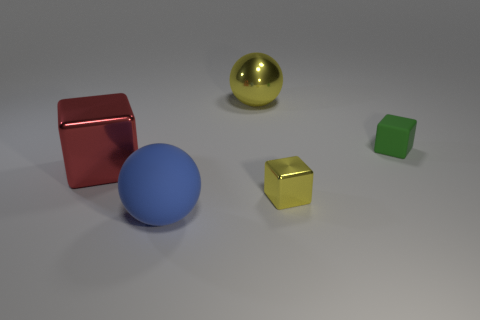Subtract all yellow blocks. How many blocks are left? 2 Subtract all cubes. How many objects are left? 2 Subtract 1 balls. How many balls are left? 1 Subtract all yellow balls. How many balls are left? 1 Add 4 tiny metal cubes. How many objects exist? 9 Subtract 0 brown cylinders. How many objects are left? 5 Subtract all brown blocks. Subtract all green balls. How many blocks are left? 3 Subtract all red cylinders. How many red cubes are left? 1 Subtract all blue matte things. Subtract all cubes. How many objects are left? 1 Add 1 yellow metal balls. How many yellow metal balls are left? 2 